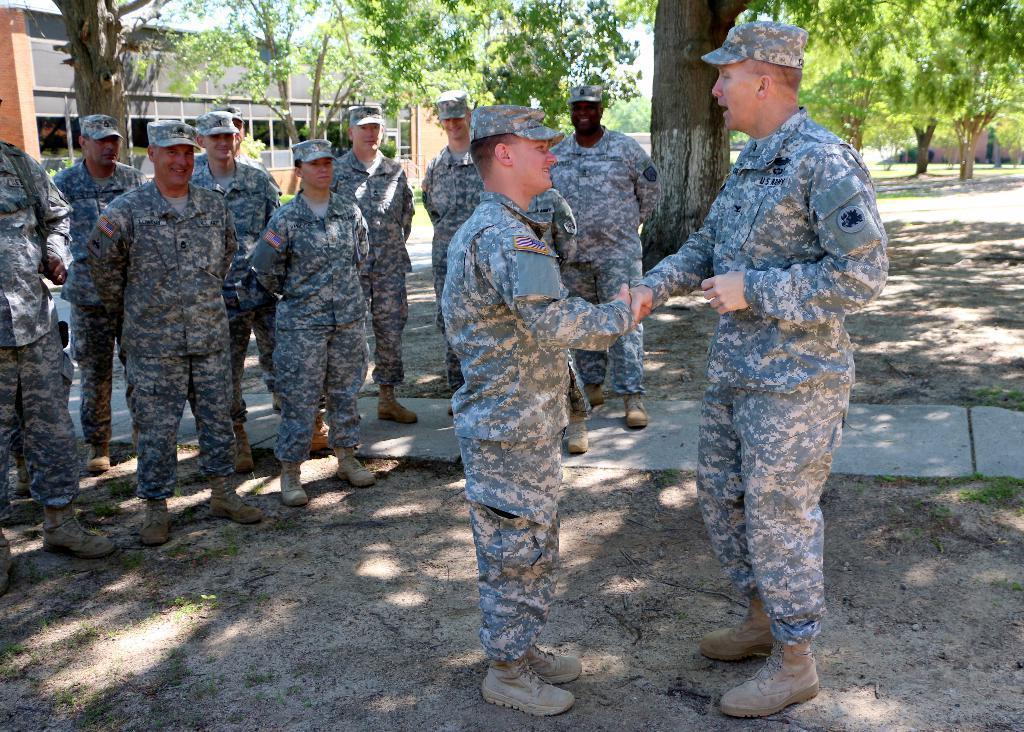How would you summarize this image in a sentence or two? In this image there are two military officers standing on the ground are shaking hands with each other. In the background there are few other military officers who are standing on the ground and smiling. In the background there are trees and buildings. On the floor there is sand and cement tiles. 